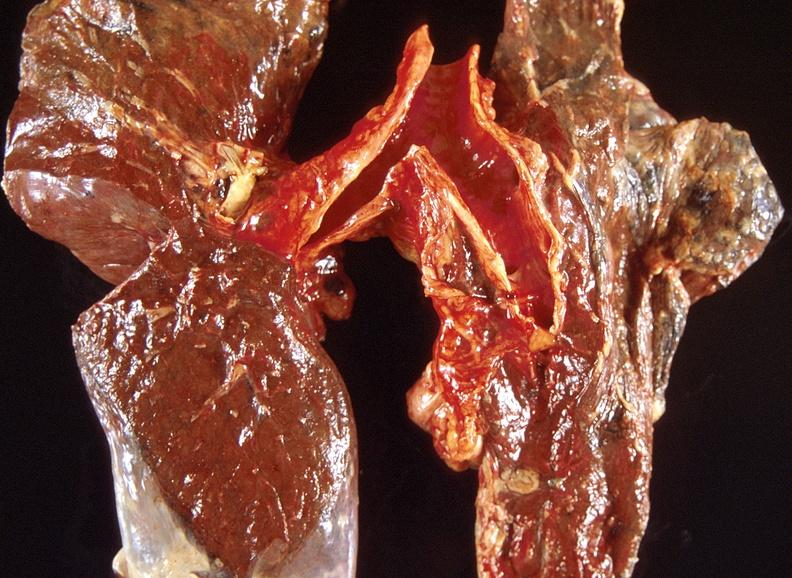what is present?
Answer the question using a single word or phrase. Respiratory 